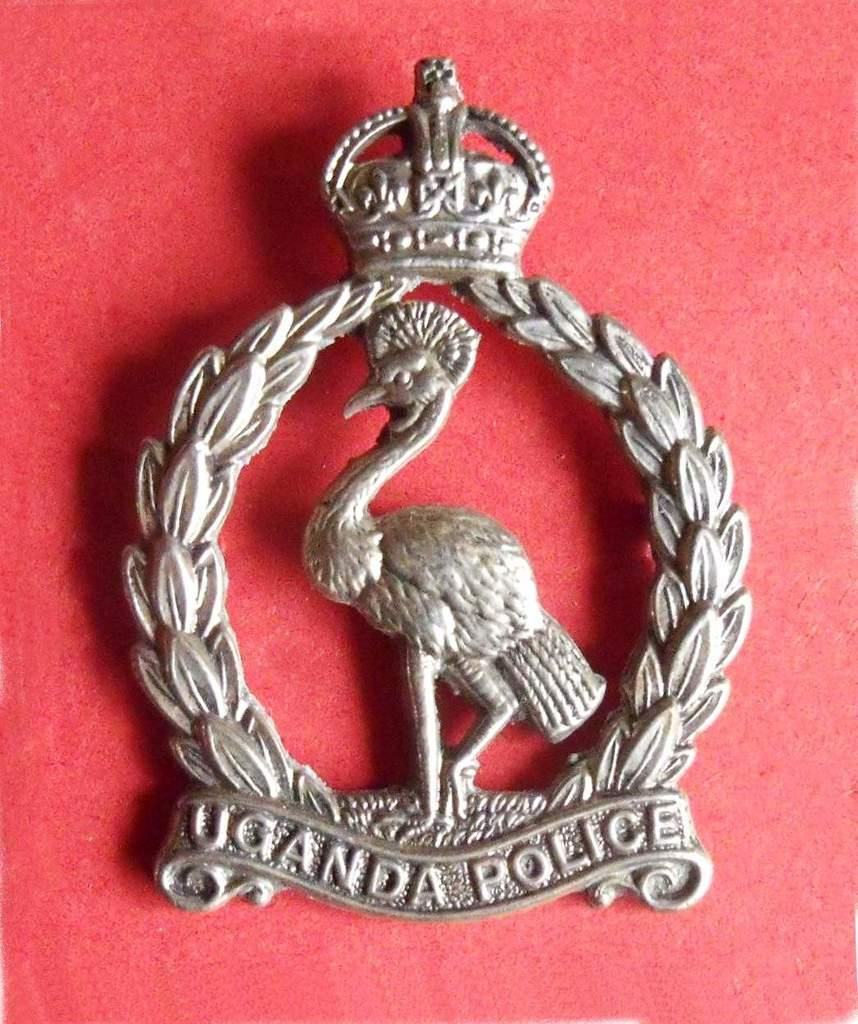What is the main object in the image? There is a badge in the image. What is depicted in the center of the badge? There is a peacock in the center of the badge. What is surrounding the peacock in the badge? There are leaves surrounding the peacock. What can be found at the bottom of the badge? There is text at the bottom of the badge. What color is the background of the badge? The background of the badge is red. What type of pain can be seen on the goose's face in the image? There is no goose present in the image, and therefore no facial expressions or pain can be observed. Can you tell me what type of guitar is being played by the peacock in the image? There is no guitar present in the image; the peacock is depicted within a badge surrounded by leaves. 